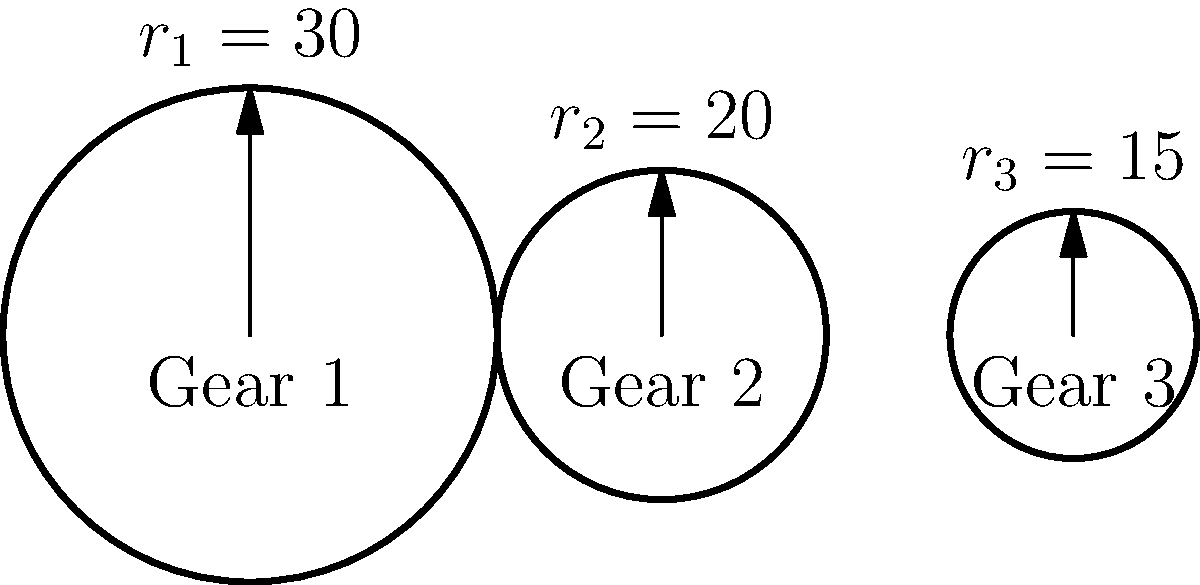Remember those old manual transmission systems in classic cars? Let's take a trip down memory lane. In the diagram above, we have three gears in a transmission system. If Gear 1 is the input gear and Gear 3 is the output gear, what is the overall gear ratio of this system? Express your answer as a fraction in its simplest form. Let's approach this step-by-step, just like we used to when working on those classic cars:

1) First, recall that the gear ratio between two meshing gears is the inverse ratio of their radii. For gears 1 and 2:

   $\text{Ratio}_{1:2} = \frac{r_2}{r_1} = \frac{20}{30} = \frac{2}{3}$

2) Similarly, for gears 2 and 3:

   $\text{Ratio}_{2:3} = \frac{r_3}{r_2} = \frac{15}{20} = \frac{3}{4}$

3) The overall gear ratio is the product of these individual ratios:

   $\text{Overall Ratio} = \text{Ratio}_{1:2} \times \text{Ratio}_{2:3} = \frac{2}{3} \times \frac{3}{4} = \frac{1}{2}$

4) This fraction is already in its simplest form.

So, just like how we used to calculate gear ratios back in the day, we've found that the overall gear ratio is 1:2 or 1/2.
Answer: $\frac{1}{2}$ 